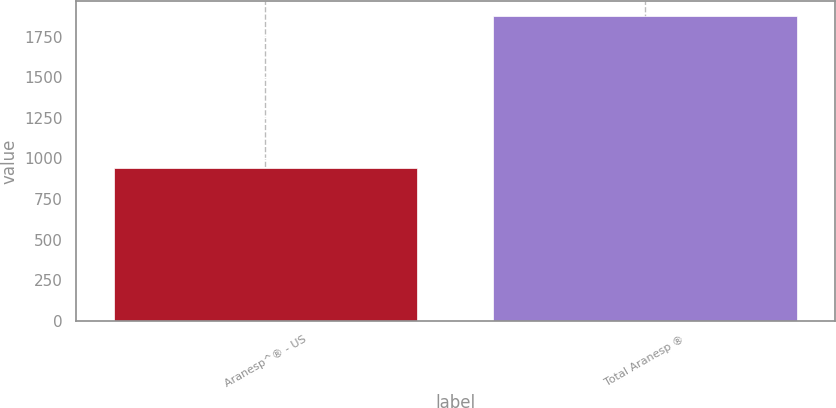Convert chart. <chart><loc_0><loc_0><loc_500><loc_500><bar_chart><fcel>Aranesp^® - US<fcel>Total Aranesp ®<nl><fcel>942<fcel>1877<nl></chart> 